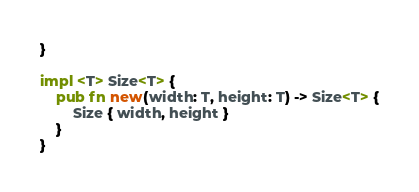<code> <loc_0><loc_0><loc_500><loc_500><_Rust_>}

impl <T> Size<T> {
    pub fn new(width: T, height: T) -> Size<T> {
        Size { width, height }
    }
}</code> 